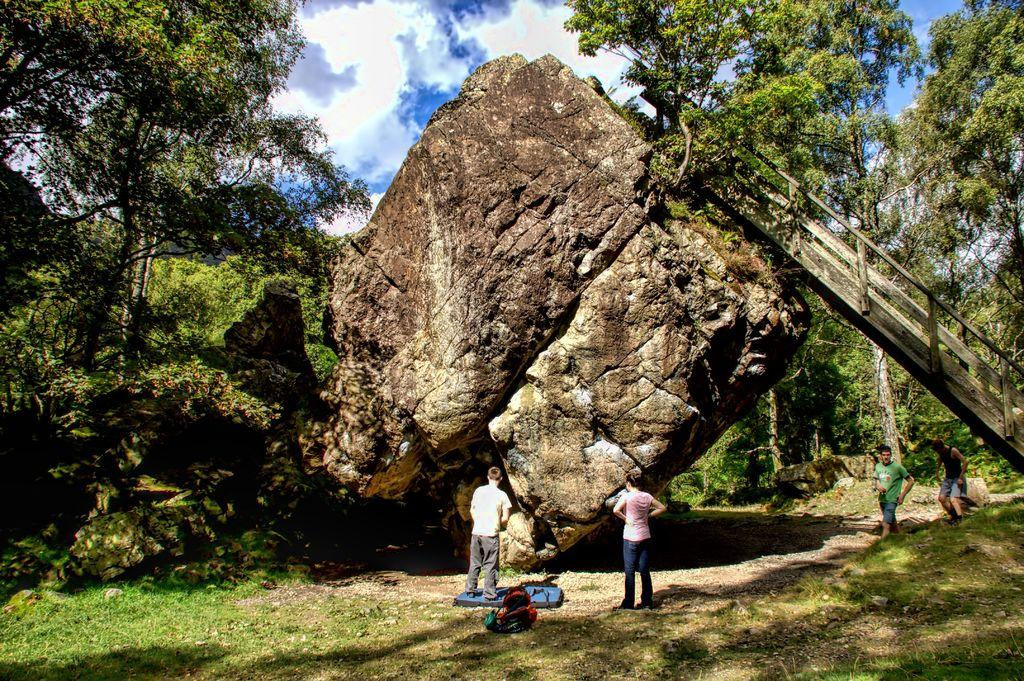What geographical feature is present in the image? There is a mountain in the image. What else can be seen in the image besides the mountain? There are people standing in the image, and there is grass on the ground. What type of vegetation is present in the image? There are green color trees in the image. What part of the natural environment is visible in the image? The sky is visible in the image. What type of work are the people doing in the image? There is no indication of work being done in the image; the people are simply standing. Is there a birthday celebration happening in the image? There is no indication of a birthday celebration in the image. 